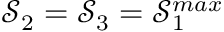Convert formula to latex. <formula><loc_0><loc_0><loc_500><loc_500>\mathcal { S } _ { 2 } = \mathcal { S } _ { 3 } = \mathcal { S } _ { 1 } ^ { \max }</formula> 